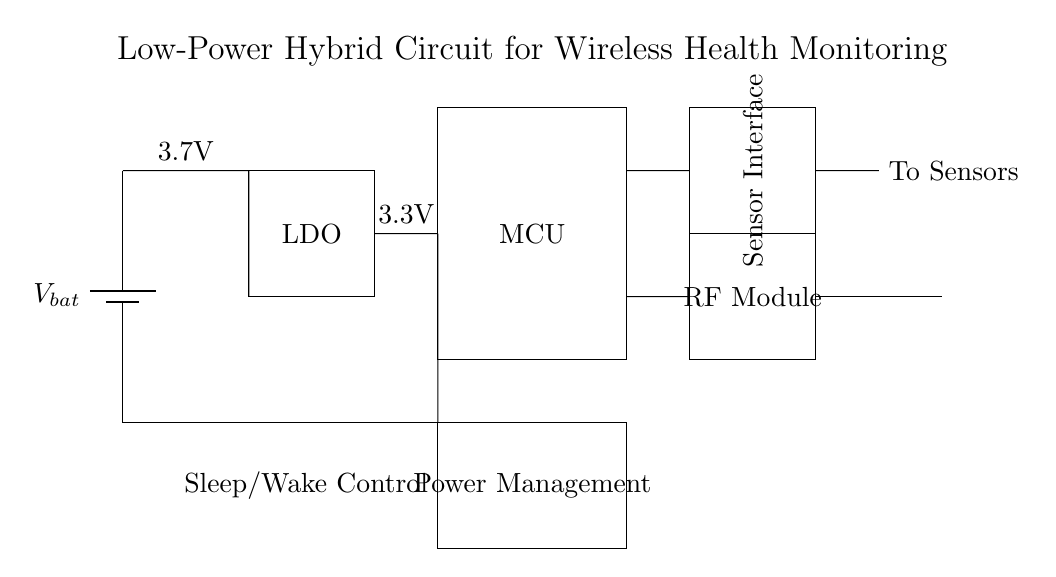What is the input voltage of the circuit? The input voltage is provided by the battery, which is labeled as 3.7V.
Answer: 3.7V What type of voltage regulator is used in the circuit? The voltage regulator used is a Low Dropout Regulator (LDO), which is indicated in the rectangle labeled 'LDO'.
Answer: LDO How many main functional blocks are present in the circuit? The main functional blocks in the circuit are: the battery, voltage regulator, microcontroller (MCU), sensor interface, wireless module, and power management, totaling six blocks.
Answer: Six What is the output voltage provided by the regulator? The output voltage from the LDO is labeled as 3.3V, which is the voltage supplied to the subsequent components.
Answer: 3.3V What is the purpose of the RF module in this circuit? The RF module is responsible for wireless data transmission, as indicated by the label 'RF Module' which connects to an antenna.
Answer: Wireless data transmission What is the function of the power management block? The power management block is indicated to manage the overall power supply, specifically labeled for sleep/wake control, which helps in optimizing power usage in the device.
Answer: Power management 